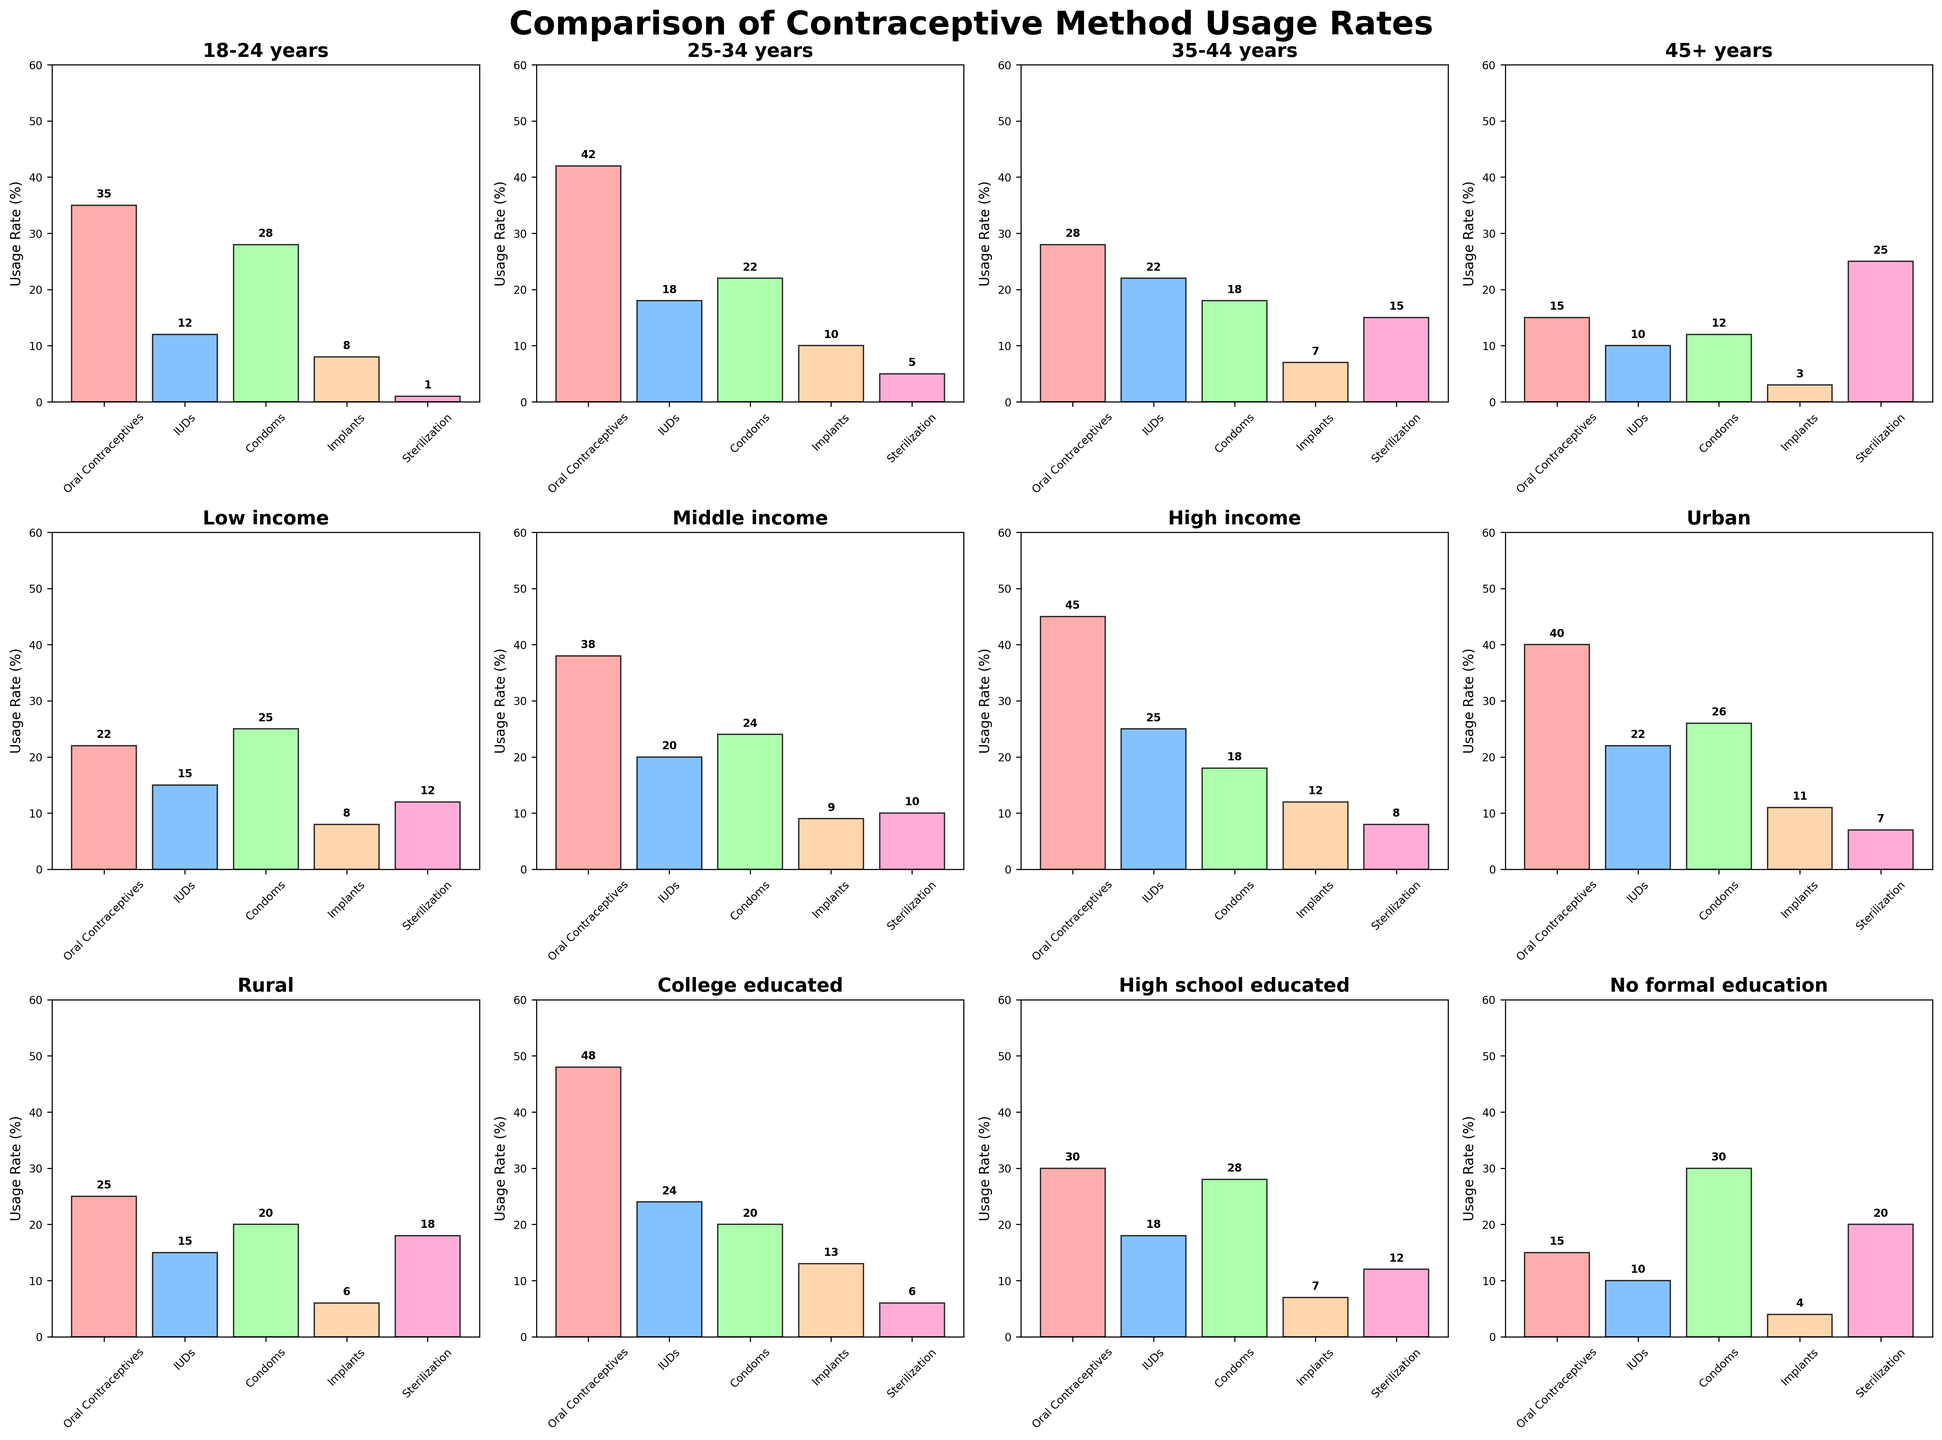What is the title of the figure? The title is at the top of the figure and usually summarized in bold to reflect the main comparison being made. The title reads 'Comparison of Contraceptive Method Usage Rates'.
Answer: Comparison of Contraceptive Method Usage Rates Which demographic has the highest usage rate of oral contraceptives? By examining each subplot, the College educated demographic has the highest bar for oral contraceptives at 48%.
Answer: College educated What is the difference in sterilization usage rates between women aged 35-44 years and those aged 45+ years? Check the heights of the bars representing sterilization for the two age groups. For 35–44 years, it's 15%, and for 45+ years, it's 25%. The difference is 25 - 15 = 10%.
Answer: 10% Which income group shows the highest use of IUDs? Looking across the subplots, the High income group shows the highest bar for IUDs usage at 25%.
Answer: High income What average values (mean) of condom usage rates are seen in rural and urban areas? Condom usage rates in Rural areas are 20%, and in Urban areas, it's 26%. The average is (20 + 26) / 2 = 23%.
Answer: 23% Is the usage of implants higher in middle-income or low-income groups? Comparing the bars for implants in both demographics: middle-income shows 9%, and low-income shows 8%. The usage is higher in the middle-income group.
Answer: Middle income What group has the lowest usage rate of oral contraceptives? The 'No formal education' group has the lowest bar for oral contraceptives, represented by a value of 15%.
Answer: No formal education How does the usage of sterilization in urban areas compare to that in rural areas? Compare the bars for sterilization in Urban areas (7%) and Rural areas (18%). The usage is higher in Rural areas.
Answer: Higher in rural areas What is the total usage rate of IUDs across all age demographics? Sum the values for IUDs: 12 (18-24) + 18 (25-34) + 22 (35-44) + 10 (45+). The total is 12 + 18 + 22 + 10 = 62%.
Answer: 62% Which education level shows the highest usage of implants? In all subplots, the College educated group shows the highest bar for implants at 13%.
Answer: College educated 